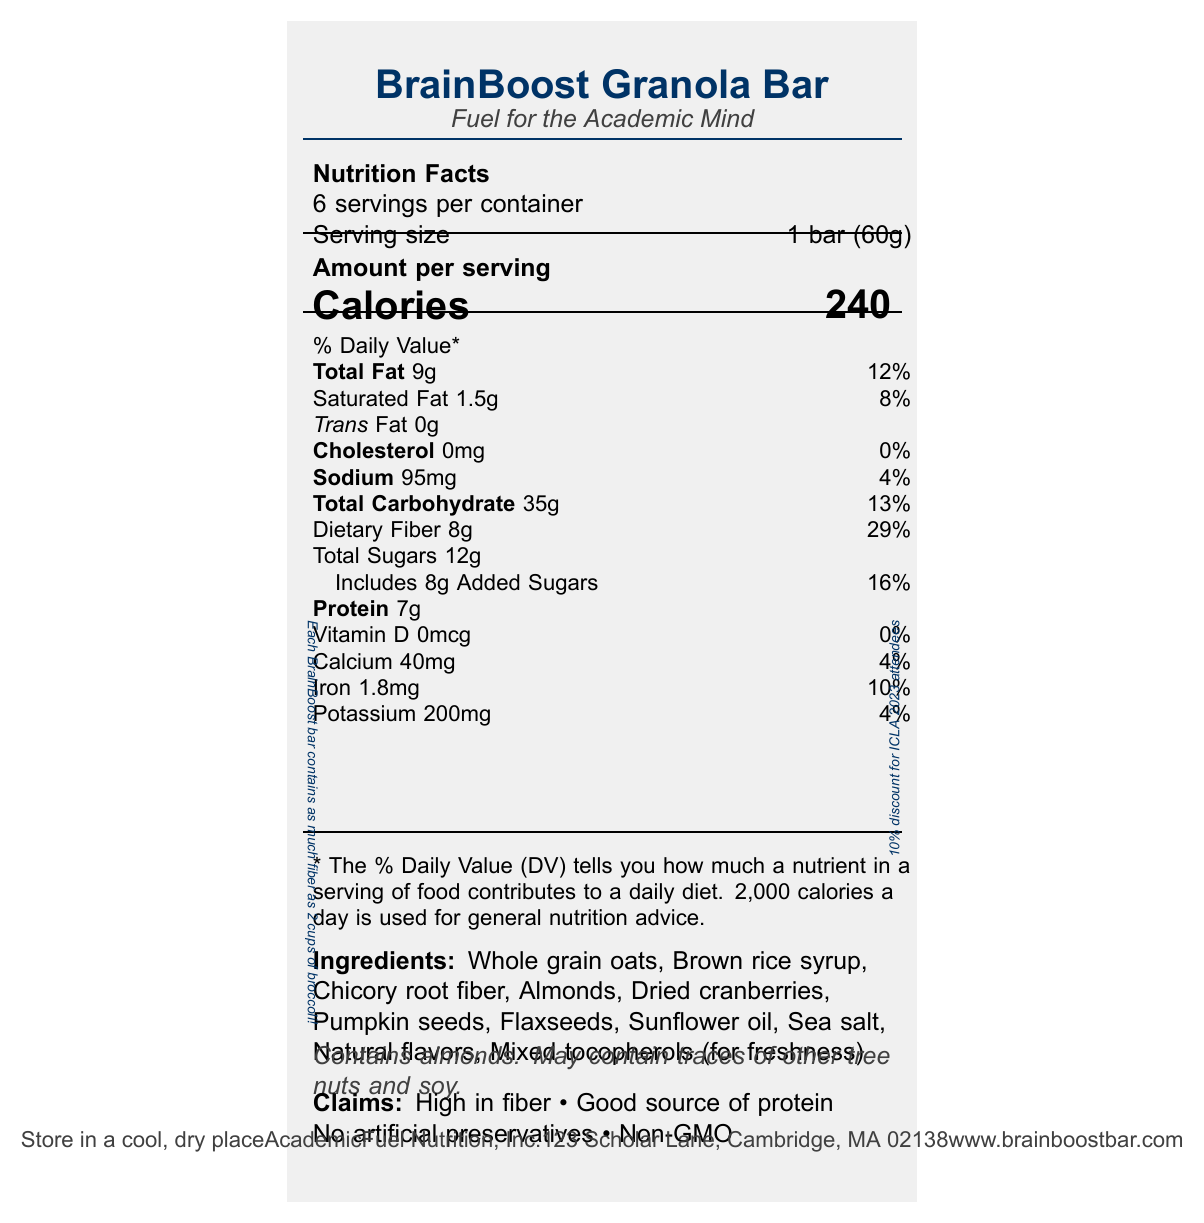what is the serving size for the BrainBoost Granola Bar? The serving size is clearly mentioned as "1 bar (60g)" in the document.
Answer: 1 bar (60g) how many calories are in one serving of the BrainBoost Granola Bar? The document states "Calories" with a value of 240.
Answer: 240 what percentage of the daily value of dietary fiber does one serving of the BrainBoost Granola Bar provide? The dietary fiber amount per serving is listed as "8g" and its daily value as "29%".
Answer: 29% what are the total sugars in one serving, and how much of it are added sugars? The document states "Total Sugars 12g" and "Includes 8g Added Sugars".
Answer: 12g total sugars, 8g added sugars what is the sodium content per serving? The sodium content is mentioned as "Sodium 95mg" in the document.
Answer: 95mg what allergens does the BrainBoost Granola Bar contain? The allergen information states "Contains almonds. May contain traces of other tree nuts and soy."
Answer: Contains almonds. May contain traces of other tree nuts and soy. Which of the following nutrients does the BrainBoost Granola Bar have the highest daily value percentage? A. Total Fat B. Dietary Fiber C. Protein D. Iron The nutrient with the highest daily value percentage is Dietary Fiber with 29%.
Answer: B. Dietary Fiber Which claim about the BrainBoost Granola Bar is explicitly mentioned in the document? A. Gluten-free B. High in fiber C. Low in sodium D. Organic The document lists "High in fiber" as one of the claims of the product.
Answer: B. High in fiber Is the BrainBoost Granola Bar a good source of protein? The claims section of the document states that the granola bar is a "Good source of protein".
Answer: Yes Does the BrainBoost Granola Bar contain any artificial preservatives? The claims in the document include "No artificial preservatives".
Answer: No Summarize the main details provided in the nutrition facts label of the BrainBoost Granola Bar. This summary captures the main nutritional components, serving details, allergens, and key claims of the product as stated in the document.
Answer: The BrainBoost Granola Bar is a high-fiber, 240-calorie snack designed for on-the-go professors attending conferences. It contains 9g of total fat, 7g of protein, and 35g of total carbohydrates per serving, which is one bar (60g). The bar is high in dietary fiber (8g) and includes 12g of total sugars of which 8g are added. It also includes essential minerals such as calcium, iron, and potassium. The product contains almonds and may have traces of other tree nuts and soy. Additional claims include being non-GMO and having no artificial preservatives. What is the exact address for the manufacturer of the BrainBoost Granola Bar? The manufacturer's address is given as "123 Scholar Lane, Cambridge, MA 02138".
Answer: 123 Scholar Lane, Cambridge, MA 02138 How many cups of broccoli are equivalent to the fiber content in each BrainBoost Bar? The fun fact at the bottom of the document states, "Each BrainBoost bar contains as much fiber as 2 cups of broccoli!"
Answer: 2 cups of broccoli What is the serving size in grams? The serving size information is given as "1 bar (60g)", but if someone asked for servings in grams otherwise, they wouldn't find enough information as the document just provides 60g per bar.
Answer: Cannot be determined 